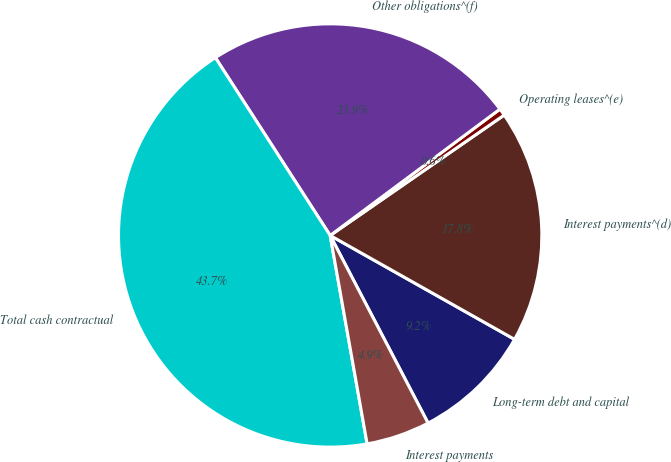Convert chart. <chart><loc_0><loc_0><loc_500><loc_500><pie_chart><fcel>Long-term debt and capital<fcel>Interest payments^(d)<fcel>Operating leases^(e)<fcel>Other obligations^(f)<fcel>Total cash contractual<fcel>Interest payments<nl><fcel>9.18%<fcel>17.8%<fcel>0.55%<fcel>23.94%<fcel>43.67%<fcel>4.86%<nl></chart> 